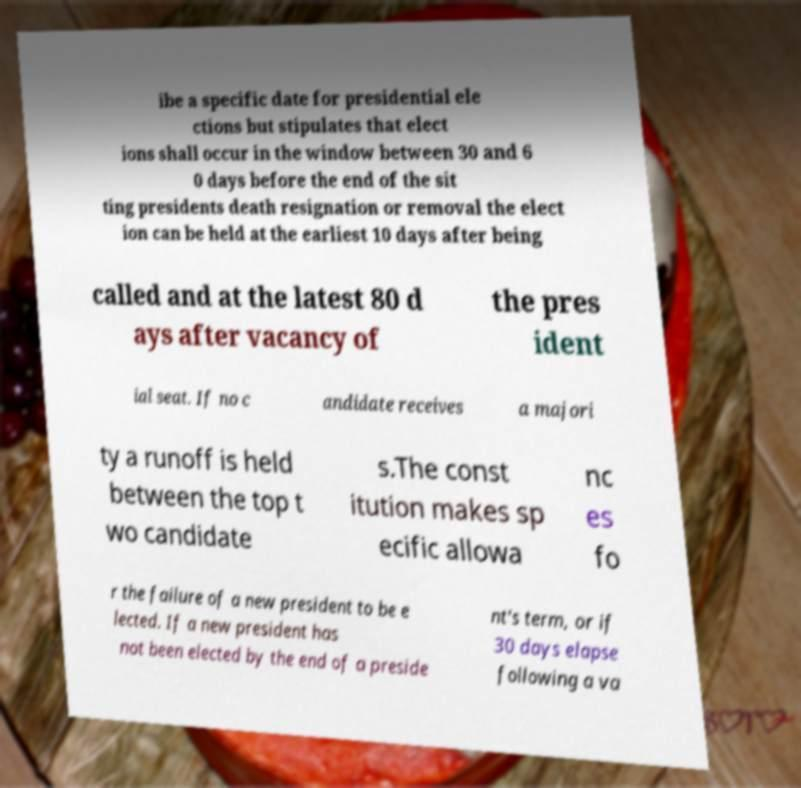Can you read and provide the text displayed in the image?This photo seems to have some interesting text. Can you extract and type it out for me? ibe a specific date for presidential ele ctions but stipulates that elect ions shall occur in the window between 30 and 6 0 days before the end of the sit ting presidents death resignation or removal the elect ion can be held at the earliest 10 days after being called and at the latest 80 d ays after vacancy of the pres ident ial seat. If no c andidate receives a majori ty a runoff is held between the top t wo candidate s.The const itution makes sp ecific allowa nc es fo r the failure of a new president to be e lected. If a new president has not been elected by the end of a preside nt's term, or if 30 days elapse following a va 